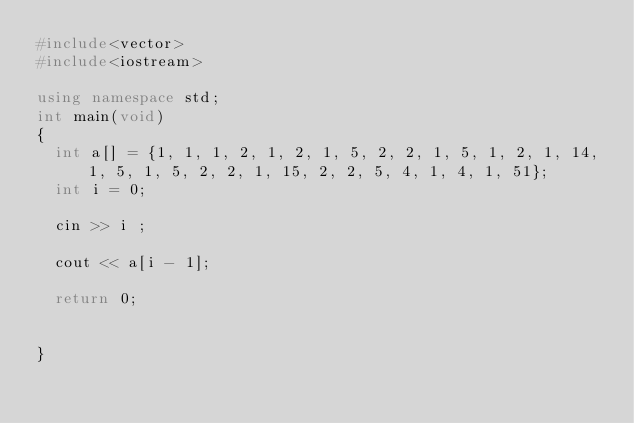Convert code to text. <code><loc_0><loc_0><loc_500><loc_500><_C++_>#include<vector>
#include<iostream>
 
using namespace std;
int main(void)
{
  int a[] = {1, 1, 1, 2, 1, 2, 1, 5, 2, 2, 1, 5, 1, 2, 1, 14, 1, 5, 1, 5, 2, 2, 1, 15, 2, 2, 5, 4, 1, 4, 1, 51};
  int i = 0;
  
  cin >> i ;
  
  cout << a[i - 1];
  
  return 0;
  
 
}</code> 